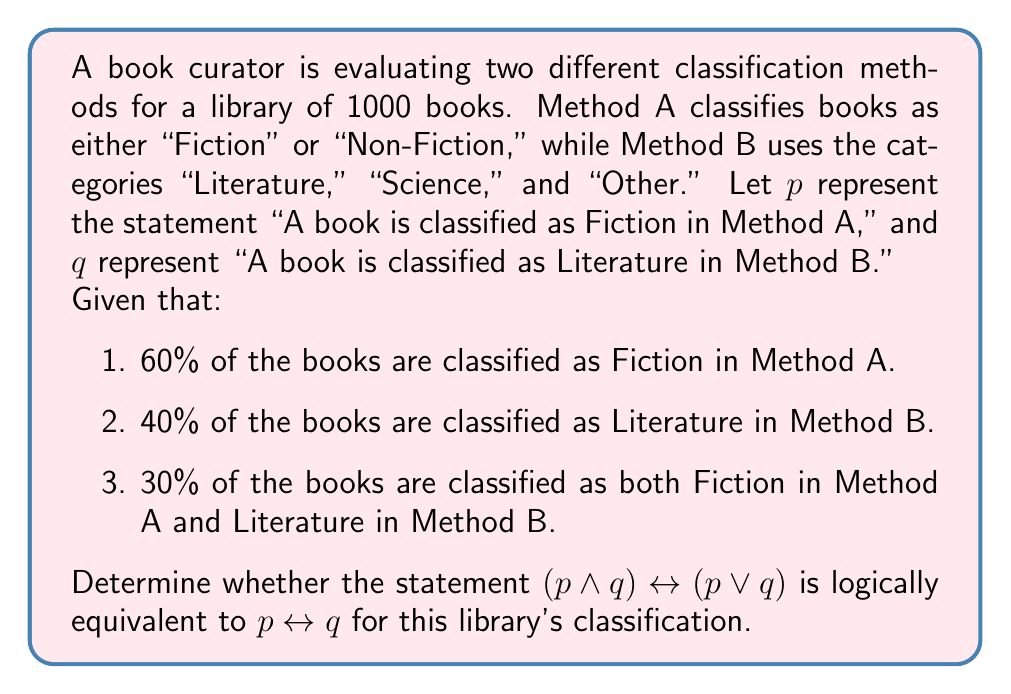Can you solve this math problem? To evaluate the logical equivalence of the two statements, we need to construct truth tables for both expressions and compare them. Let's break this down step-by-step:

1. First, let's calculate the probabilities for each combination of $p$ and $q$:

   $P(p) = 0.60$
   $P(q) = 0.40$
   $P(p \land q) = 0.30$
   $P(p \lor q) = P(p) + P(q) - P(p \land q) = 0.60 + 0.40 - 0.30 = 0.70$

2. Now, let's construct truth tables for both expressions:

   For $(p \land q) \leftrightarrow (p \lor q)$:

   | $p$ | $q$ | $p \land q$ | $p \lor q$ | $(p \land q) \leftrightarrow (p \lor q)$ |
   |-----|-----|-------------|------------|------------------------------------------|
   | T   | T   | T           | T          | T                                        |
   | T   | F   | F           | T          | F                                        |
   | F   | T   | F           | T          | F                                        |
   | F   | F   | F           | F          | T                                        |

   For $p \leftrightarrow q$:

   | $p$ | $q$ | $p \leftrightarrow q$ |
   |-----|-----|------------------------|
   | T   | T   | T                      |
   | T   | F   | F                      |
   | F   | T   | F                      |
   | F   | F   | T                      |

3. Comparing the truth tables, we can see that both expressions have the same truth values for all possible combinations of $p$ and $q$. This means that the two expressions are logically equivalent.

4. To further verify this, we can use the given probabilities:

   $P((p \land q) \leftrightarrow (p \lor q)) = P(p \land q) + P(\lnot p \land \lnot q) = 0.30 + 0.30 = 0.60$

   $P(p \leftrightarrow q) = P(p \land q) + P(\lnot p \land \lnot q) = 0.30 + 0.30 = 0.60$

   The probabilities are equal, confirming the logical equivalence.
Answer: Yes, the statement $(p \land q) \leftrightarrow (p \lor q)$ is logically equivalent to $p \leftrightarrow q$ for this library's classification. 